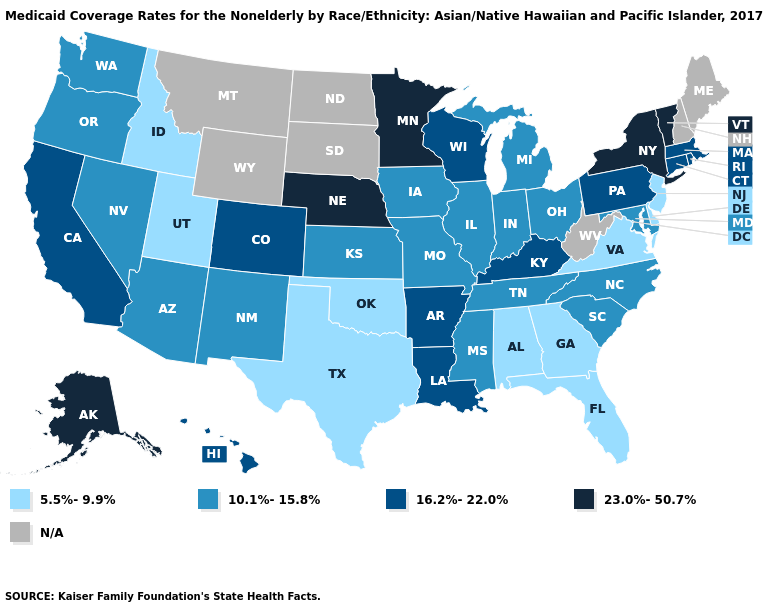What is the highest value in the Northeast ?
Write a very short answer. 23.0%-50.7%. What is the highest value in the West ?
Keep it brief. 23.0%-50.7%. Does Missouri have the highest value in the USA?
Keep it brief. No. What is the highest value in the Northeast ?
Answer briefly. 23.0%-50.7%. What is the value of Hawaii?
Give a very brief answer. 16.2%-22.0%. What is the highest value in the Northeast ?
Give a very brief answer. 23.0%-50.7%. Name the states that have a value in the range 16.2%-22.0%?
Answer briefly. Arkansas, California, Colorado, Connecticut, Hawaii, Kentucky, Louisiana, Massachusetts, Pennsylvania, Rhode Island, Wisconsin. How many symbols are there in the legend?
Answer briefly. 5. Does Alaska have the highest value in the USA?
Short answer required. Yes. Name the states that have a value in the range 23.0%-50.7%?
Quick response, please. Alaska, Minnesota, Nebraska, New York, Vermont. What is the value of Texas?
Keep it brief. 5.5%-9.9%. Does Missouri have the highest value in the USA?
Write a very short answer. No. Among the states that border Massachusetts , which have the lowest value?
Short answer required. Connecticut, Rhode Island. 